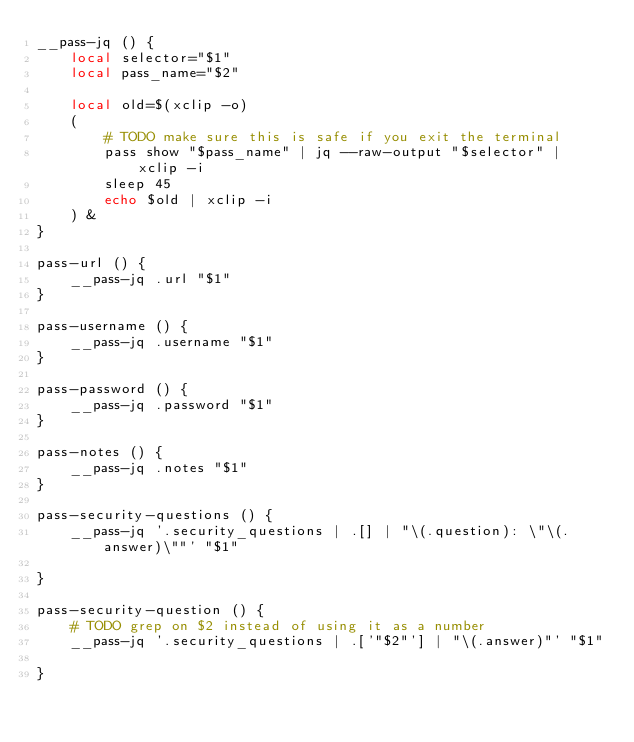Convert code to text. <code><loc_0><loc_0><loc_500><loc_500><_Bash_>__pass-jq () {
    local selector="$1"
    local pass_name="$2"

    local old=$(xclip -o)
    (
        # TODO make sure this is safe if you exit the terminal
        pass show "$pass_name" | jq --raw-output "$selector" | xclip -i
        sleep 45
        echo $old | xclip -i
    ) &
}

pass-url () {
    __pass-jq .url "$1"
}

pass-username () {
    __pass-jq .username "$1"
}

pass-password () {
    __pass-jq .password "$1"
}

pass-notes () {
    __pass-jq .notes "$1"
}

pass-security-questions () {
    __pass-jq '.security_questions | .[] | "\(.question): \"\(.answer)\""' "$1"

}

pass-security-question () {
    # TODO grep on $2 instead of using it as a number
    __pass-jq '.security_questions | .['"$2"'] | "\(.answer)"' "$1"

}
</code> 